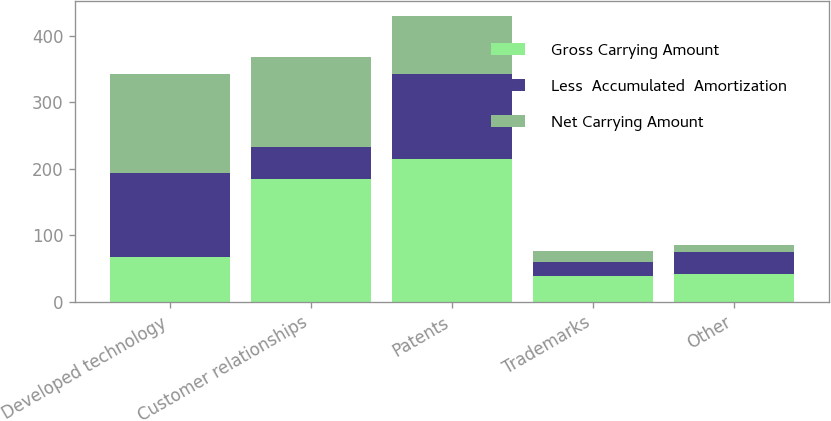Convert chart. <chart><loc_0><loc_0><loc_500><loc_500><stacked_bar_chart><ecel><fcel>Developed technology<fcel>Customer relationships<fcel>Patents<fcel>Trademarks<fcel>Other<nl><fcel>Gross Carrying Amount<fcel>68.2<fcel>184.1<fcel>215<fcel>38.3<fcel>42.6<nl><fcel>Less  Accumulated  Amortization<fcel>125.7<fcel>48.8<fcel>127.4<fcel>22.4<fcel>31.9<nl><fcel>Net Carrying Amount<fcel>148.6<fcel>135.3<fcel>87.6<fcel>15.9<fcel>10.7<nl></chart> 